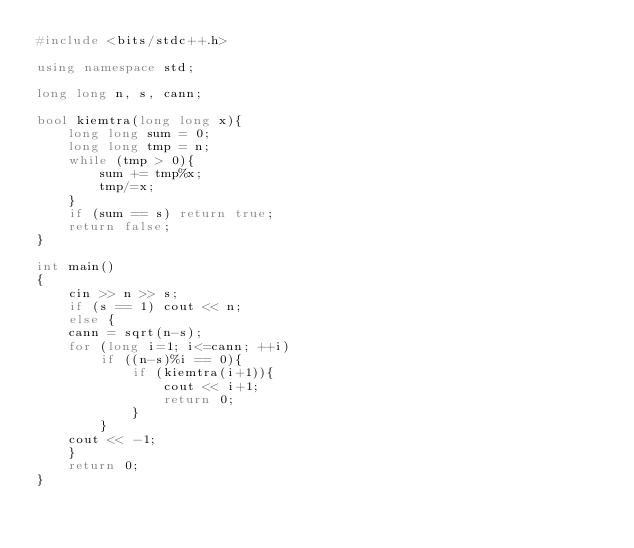<code> <loc_0><loc_0><loc_500><loc_500><_C++_>#include <bits/stdc++.h>

using namespace std;

long long n, s, cann;

bool kiemtra(long long x){
    long long sum = 0;
    long long tmp = n;
    while (tmp > 0){
        sum += tmp%x;
        tmp/=x;
    }
    if (sum == s) return true;
    return false;
}

int main()
{
    cin >> n >> s;
    if (s == 1) cout << n;
    else {
    cann = sqrt(n-s);
    for (long i=1; i<=cann; ++i)
        if ((n-s)%i == 0){
            if (kiemtra(i+1)){
                cout << i+1;
                return 0;
            }
        }
    cout << -1;
    }
    return 0;
}
</code> 